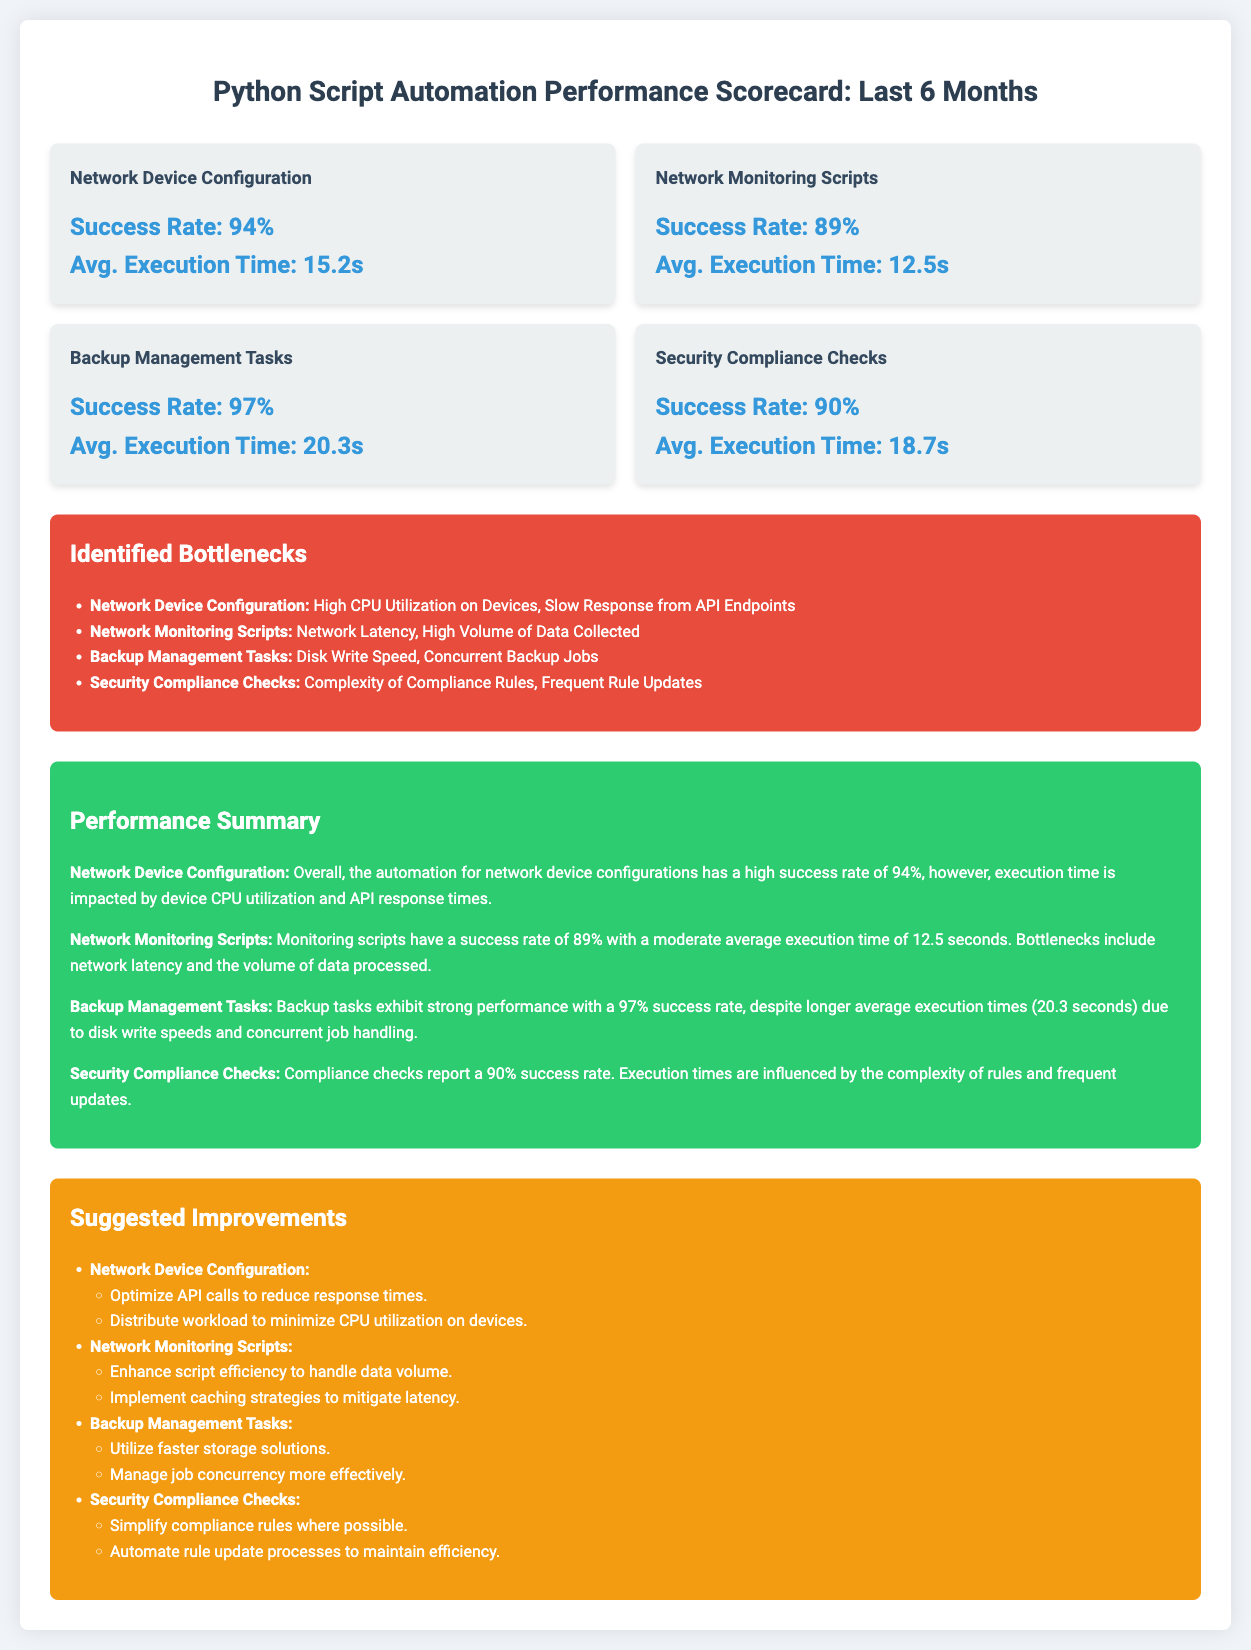What is the success rate for Network Device Configuration? The success rate for Network Device Configuration is listed in the document as 94%.
Answer: 94% What is the average execution time for Backup Management Tasks? The document states that the average execution time for Backup Management Tasks is 20.3 seconds.
Answer: 20.3 seconds What bottleneck is identified for Network Monitoring Scripts? The identified bottlenecks for Network Monitoring Scripts include Network Latency and High Volume of Data Collected as mentioned in the document.
Answer: Network Latency, High Volume of Data Collected What is the success rate of Security Compliance Checks? The document provides that the success rate for Security Compliance Checks is 90%.
Answer: 90% What improvement is suggested for Network Device Configuration? One suggested improvement for Network Device Configuration is to optimize API calls to reduce response times according to the document.
Answer: Optimize API calls to reduce response times What is the highest success rate among the tasks listed? The document indicates that the highest success rate among the tasks listed is for Backup Management Tasks at 97%.
Answer: 97% What is the average execution time for Network Monitoring Scripts? The average execution time for Network Monitoring Scripts is stated in the document as 12.5 seconds.
Answer: 12.5 seconds What improvement is suggested for Backup Management Tasks? The document suggests utilizing faster storage solutions as an improvement for Backup Management Tasks.
Answer: Utilize faster storage solutions Which task has the lowest success rate according to the scorecard? The task with the lowest success rate according to the scorecard is Network Monitoring Scripts at 89%.
Answer: 89% 